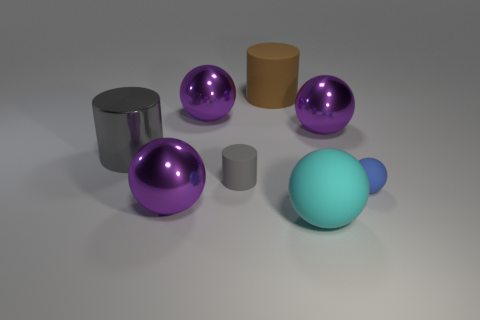Subtract all purple balls. How many were subtracted if there are1purple balls left? 2 Subtract all blue cylinders. How many purple balls are left? 3 Subtract 1 balls. How many balls are left? 4 Subtract all yellow cylinders. Subtract all green spheres. How many cylinders are left? 3 Add 1 big cyan balls. How many objects exist? 9 Subtract all cylinders. How many objects are left? 5 Add 8 small rubber cylinders. How many small rubber cylinders are left? 9 Add 1 rubber cylinders. How many rubber cylinders exist? 3 Subtract 0 green cubes. How many objects are left? 8 Subtract all cyan rubber things. Subtract all large cyan rubber objects. How many objects are left? 6 